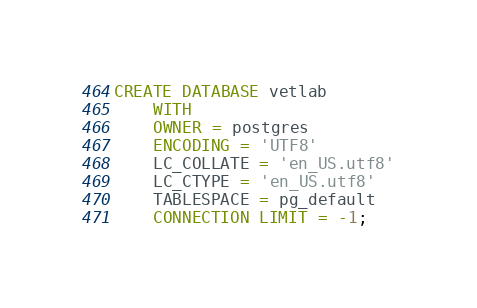<code> <loc_0><loc_0><loc_500><loc_500><_SQL_>CREATE DATABASE vetlab
    WITH
    OWNER = postgres
    ENCODING = 'UTF8'
    LC_COLLATE = 'en_US.utf8'
    LC_CTYPE = 'en_US.utf8'
    TABLESPACE = pg_default
    CONNECTION LIMIT = -1;</code> 